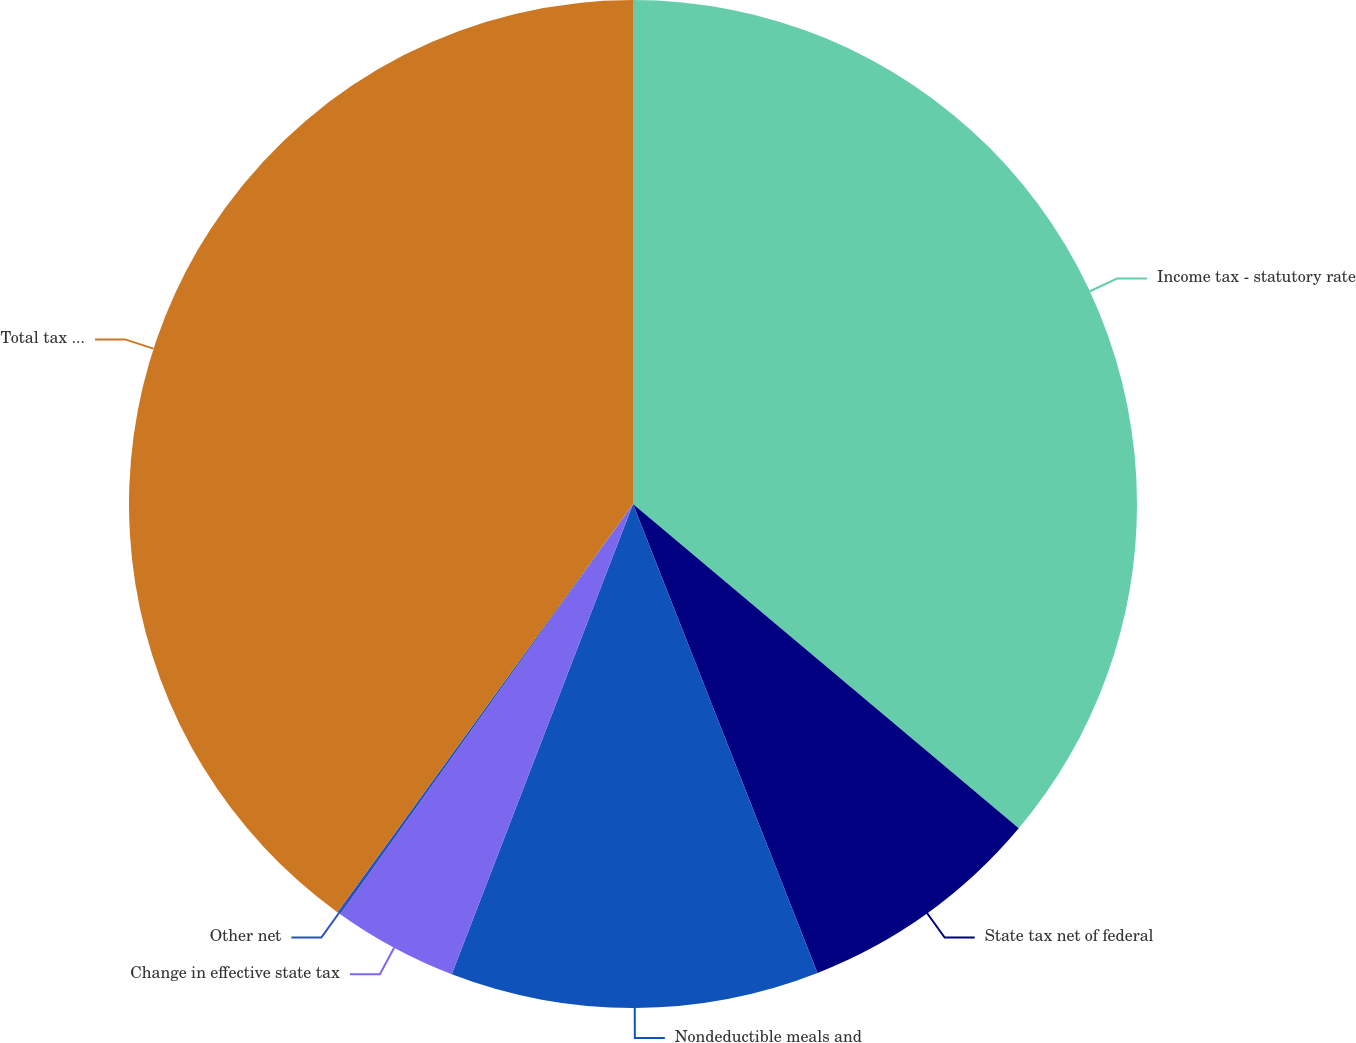Convert chart. <chart><loc_0><loc_0><loc_500><loc_500><pie_chart><fcel>Income tax - statutory rate<fcel>State tax net of federal<fcel>Nondeductible meals and<fcel>Change in effective state tax<fcel>Other net<fcel>Total tax expense<nl><fcel>36.13%<fcel>7.91%<fcel>11.82%<fcel>4.01%<fcel>0.11%<fcel>40.03%<nl></chart> 